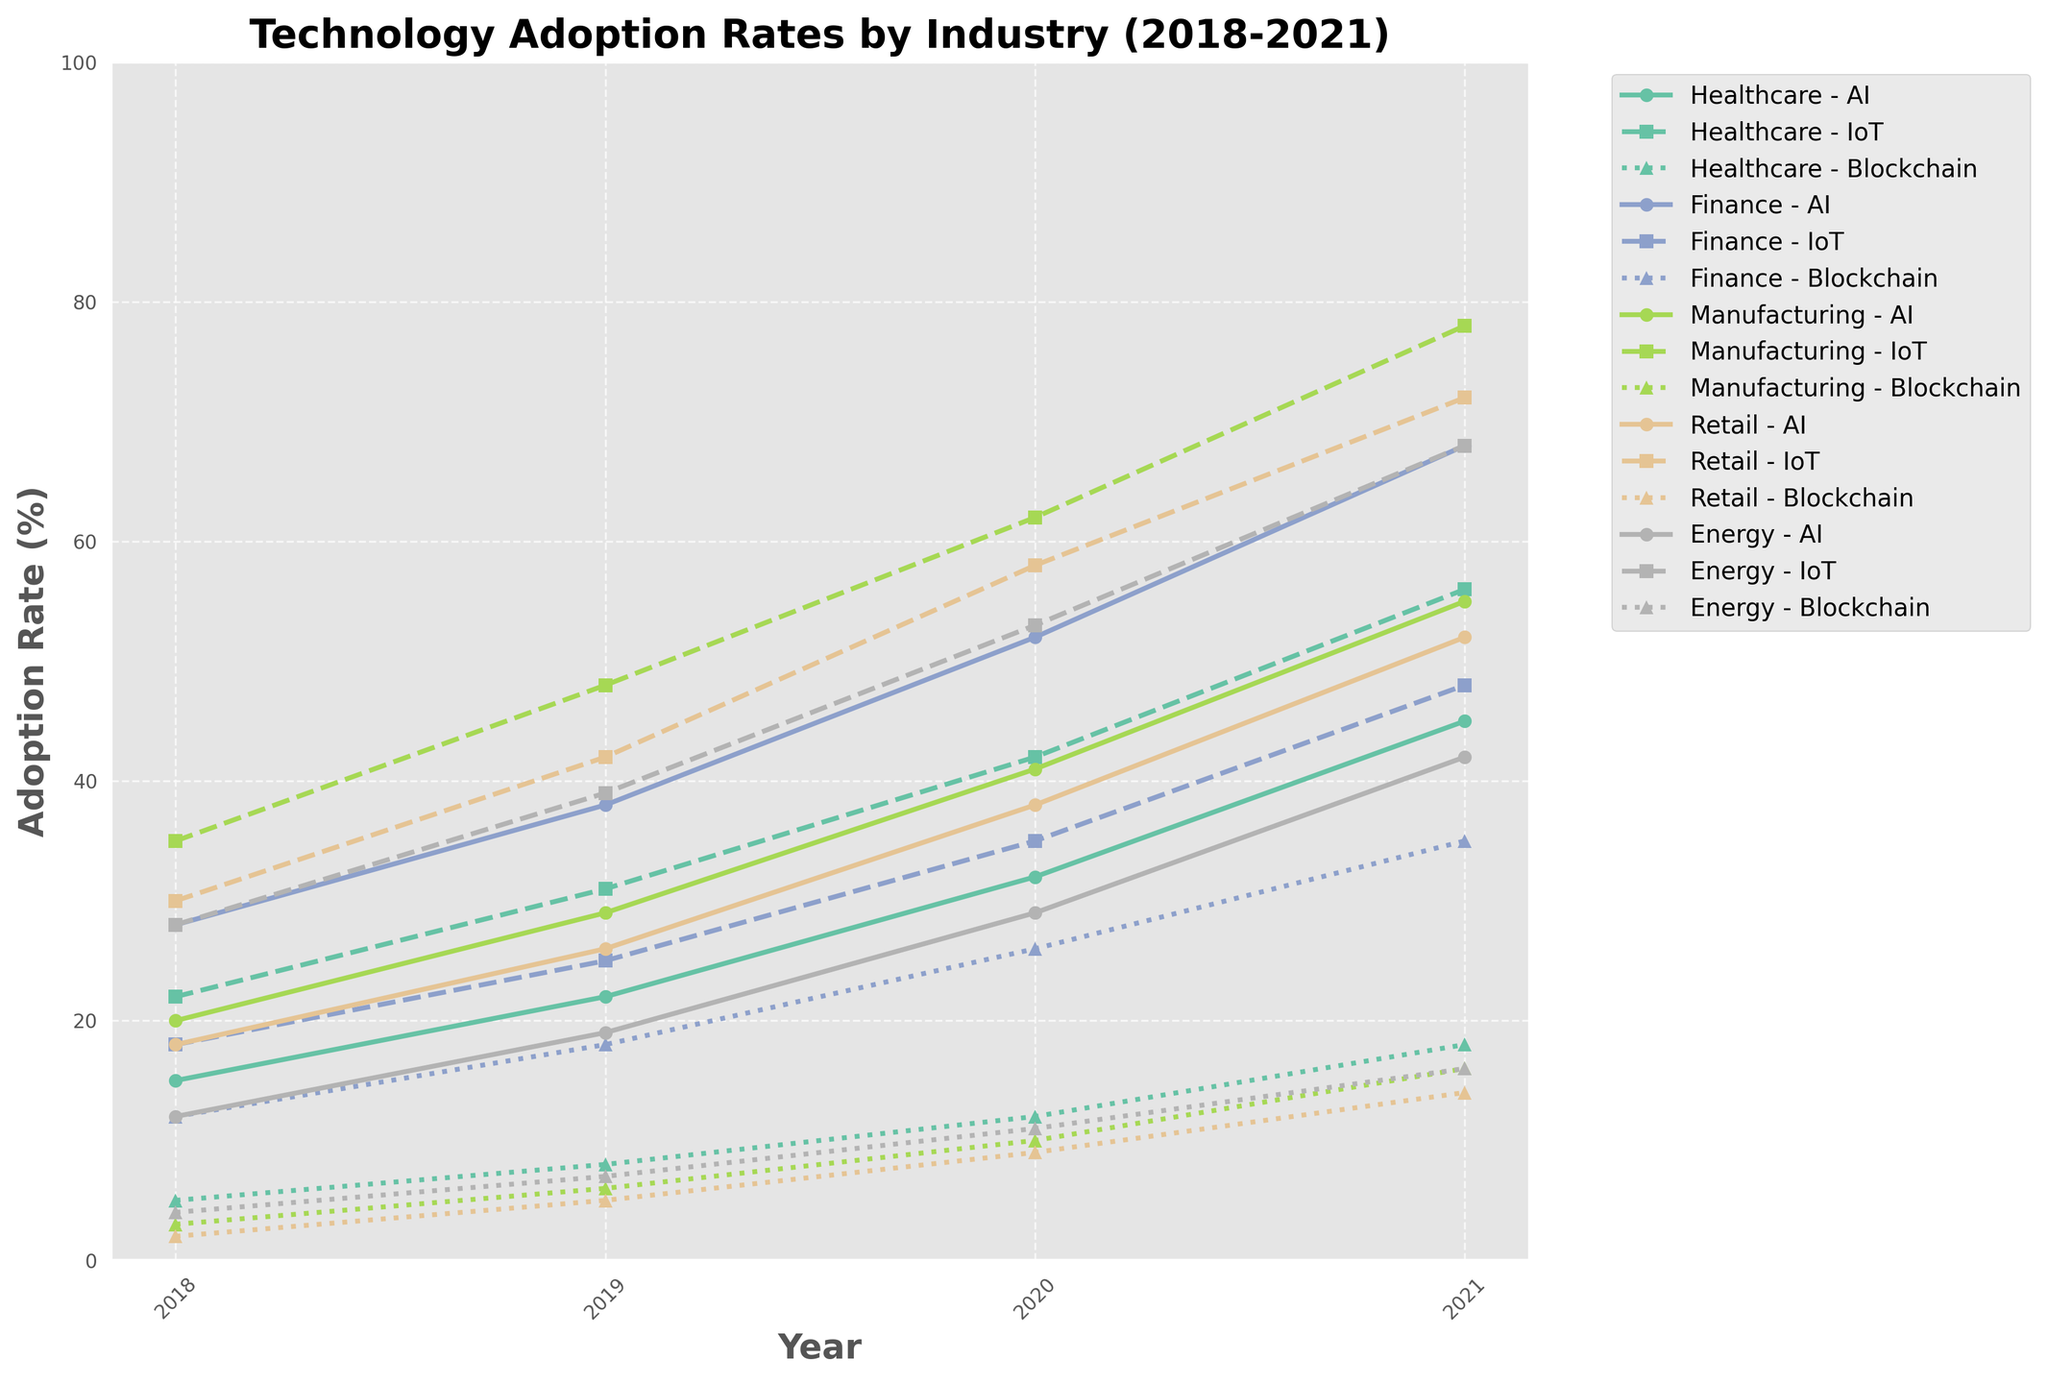What industry saw the highest AI adoption rate in 2021? To find the industry with the highest AI adoption rate in 2021, examine the heights of the lines representing AI adoption for each industry in 2021. The finance line reaches the highest point among all industries.
Answer: Finance How much did the AI adoption rate in the healthcare industry increase from 2018 to 2021? Look at the AI adoption rates for the healthcare industry in 2018 and 2021. Subtract the 2018 adoption rate from the 2021 adoption rate (45% - 15% = 30%).
Answer: 30% Which technology had the steepest increase in adoption in the retail industry from 2019 to 2020? Compare the slopes of the lines representing each technology (AI, IoT, Blockchain) in the retail industry between 2019 and 2020. The steepest slope corresponds to the largest increase. The IoT adoption rate line is the steepest between these years.
Answer: IoT Across all years, which industry had the lowest blockchain adoption rate in 2018? Look at the heights of the lines representing blockchain adoption across different industries in 2018. The retail industry has the lowest adoption rate.
Answer: Retail Which industry had a higher IoT adoption rate in 2020: energy or manufacturing? Compare the heights of the lines representing IoT adoption rates for energy and manufacturing industries in 2020. The manufacturing industry's IoT line is higher.
Answer: Manufacturing In 2021, which technology adoption rate was lower in the energy industry compared to the other technologies within the same industry? Examine the heights of the lines representing AI, IoT, and blockchain adoption for the energy industry in 2021. Blockchain adoption has the lowest rate among the three technologies.
Answer: Blockchain 